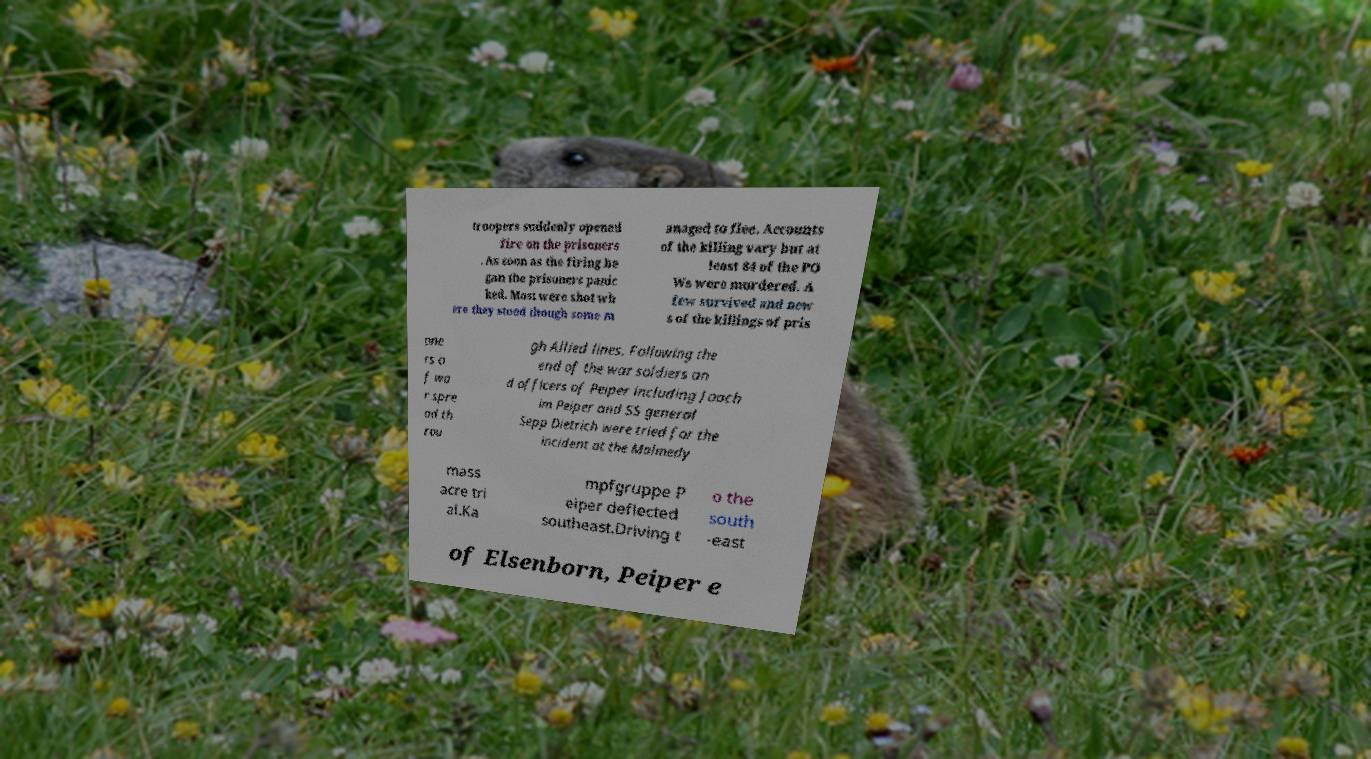For documentation purposes, I need the text within this image transcribed. Could you provide that? troopers suddenly opened fire on the prisoners . As soon as the firing be gan the prisoners panic ked. Most were shot wh ere they stood though some m anaged to flee. Accounts of the killing vary but at least 84 of the PO Ws were murdered. A few survived and new s of the killings of pris one rs o f wa r spre ad th rou gh Allied lines. Following the end of the war soldiers an d officers of Peiper including Joach im Peiper and SS general Sepp Dietrich were tried for the incident at the Malmedy mass acre tri al.Ka mpfgruppe P eiper deflected southeast.Driving t o the south -east of Elsenborn, Peiper e 